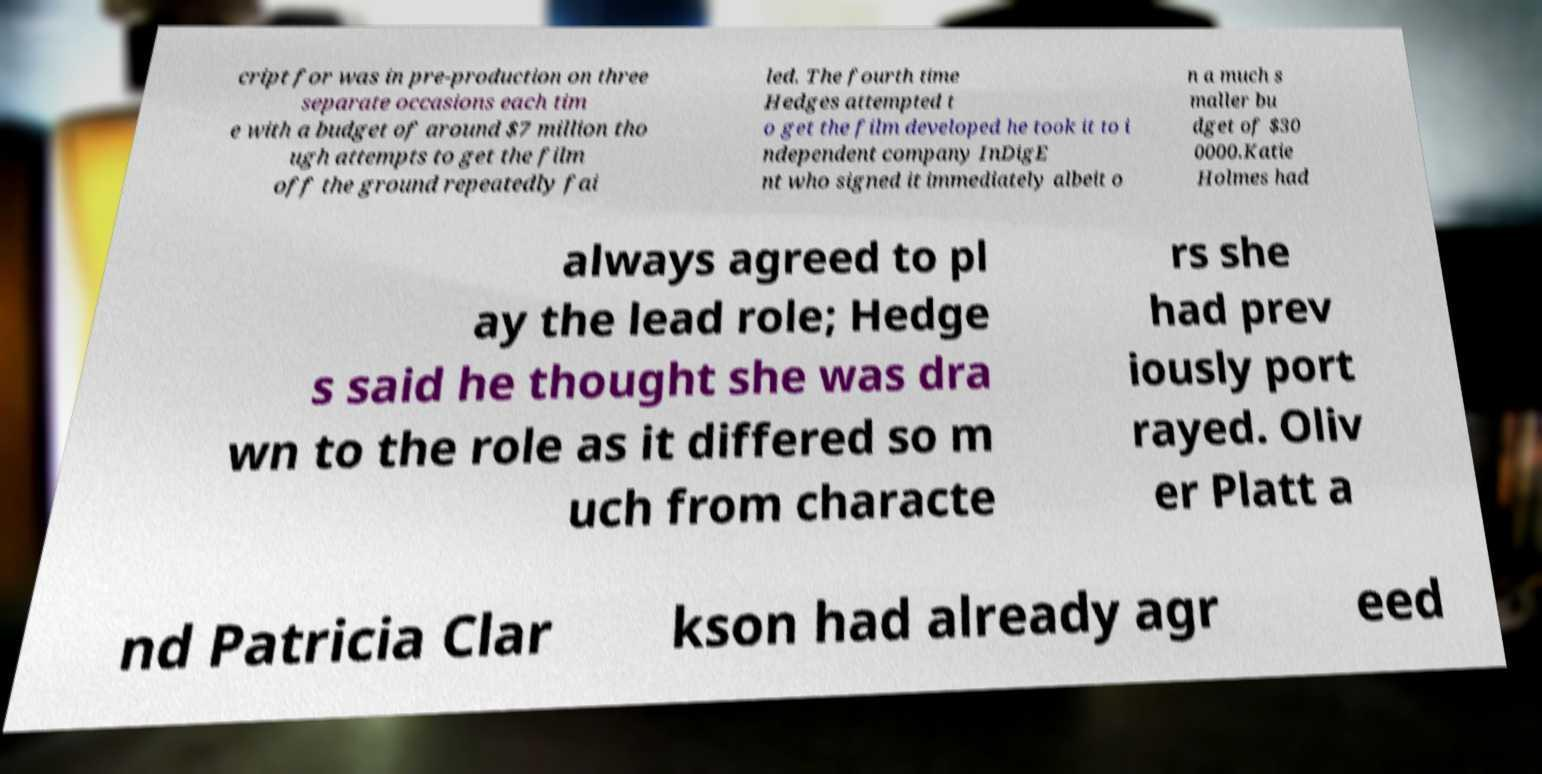For documentation purposes, I need the text within this image transcribed. Could you provide that? cript for was in pre-production on three separate occasions each tim e with a budget of around $7 million tho ugh attempts to get the film off the ground repeatedly fai led. The fourth time Hedges attempted t o get the film developed he took it to i ndependent company InDigE nt who signed it immediately albeit o n a much s maller bu dget of $30 0000.Katie Holmes had always agreed to pl ay the lead role; Hedge s said he thought she was dra wn to the role as it differed so m uch from characte rs she had prev iously port rayed. Oliv er Platt a nd Patricia Clar kson had already agr eed 